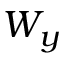<formula> <loc_0><loc_0><loc_500><loc_500>W _ { y }</formula> 